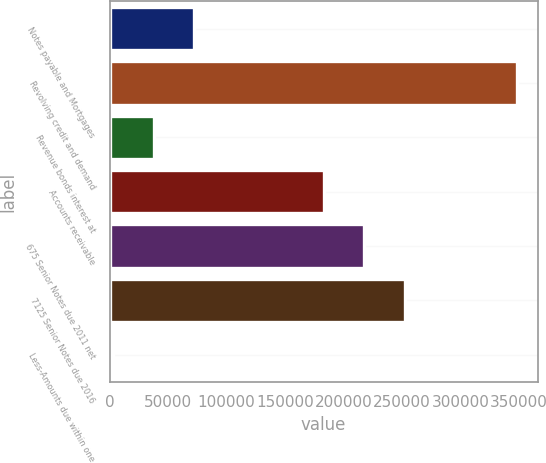Convert chart to OTSL. <chart><loc_0><loc_0><loc_500><loc_500><bar_chart><fcel>Notes payable and Mortgages<fcel>Revolving credit and demand<fcel>Revenue bonds interest at<fcel>Accounts receivable<fcel>675 Senior Notes due 2011 net<fcel>7125 Senior Notes due 2016<fcel>Less-Amounts due within one<nl><fcel>72132.8<fcel>348200<fcel>37624.4<fcel>183100<fcel>217608<fcel>252117<fcel>3116<nl></chart> 